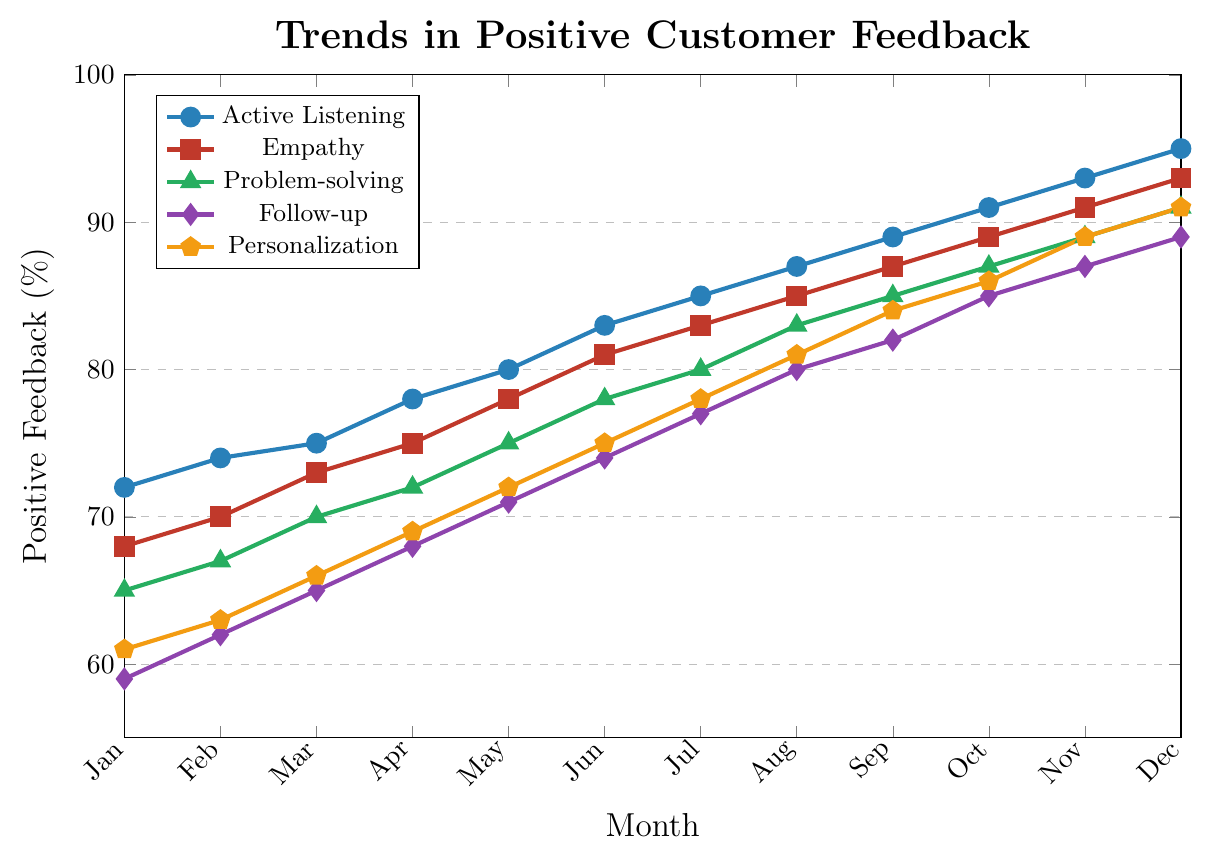What is the month with the highest positive feedback for Active Listening, and what is the value? To find the month with the highest feedback for Active Listening, inspect the line corresponding to Active Listening. The highest point occurs in December, with a value of 95%.
Answer: December, 95% Which technique showed the most consistent increase in positive feedback over the 12-month period? To determine consistency, observe the smoothness and uniformity of the line slopes. Active Listening, Empathy, Problem-solving, Follow-up, and Personalization all show steady increases, but Active Listening and Empathy exhibit the most consistent incremental gains without any significant dips.
Answer: Active Listening and Empathy What is the difference in positive feedback between June and December for the Problem-solving technique? Locate the values for Problem-solving in June (78%) and December (91%). Subtract the June value from the December value: 91% - 78% = 13%.
Answer: 13% By how much did the positive feedback for Empathy increase from the start to the end of the year? Look at the values for Empathy in January (68%) and December (93%). Calculate the difference: 93% - 68% = 25%.
Answer: 25% Which technique had the lowest positive feedback in January, and what was the value? Identify the lowest value among all techniques in January: Active Listening (72%), Empathy (68%), Problem-solving (65%), Follow-up (59%), Personalization (61%). Follow-up has the lowest value at 59%.
Answer: Follow-up, 59% Which two techniques had their feedback percentages meet or cross each other? Comparing all lines, Empathy and Problem-solving get close but never meet. All techniques show distinct upward trends without intersections, maintaining constant relative positions.
Answer: None Calculate the average positive feedback for Follow-up over the 12 months. Sum the values for Follow-up across each month and divide by 12. Summation: 59 + 62 + 65 + 68 + 71 + 74 + 77 + 80 + 82 + 85 + 87 + 89 = 889. Average: 889 / 12 ≈ 74.08%.
Answer: 74.08% Which technique exhibited the highest exponential-like growth curve? Examine each line's steepness and acceleration visually. Active Listening shows the steepest and most consistent upward growth, suggesting an exponential-like pattern.
Answer: Active Listening 